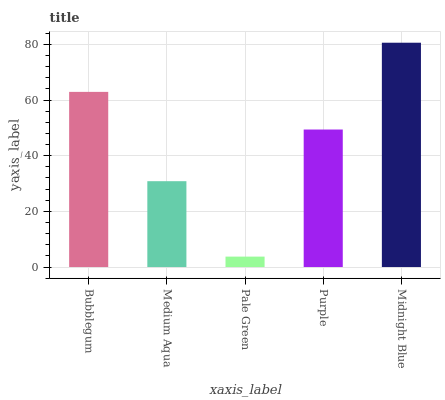Is Pale Green the minimum?
Answer yes or no. Yes. Is Midnight Blue the maximum?
Answer yes or no. Yes. Is Medium Aqua the minimum?
Answer yes or no. No. Is Medium Aqua the maximum?
Answer yes or no. No. Is Bubblegum greater than Medium Aqua?
Answer yes or no. Yes. Is Medium Aqua less than Bubblegum?
Answer yes or no. Yes. Is Medium Aqua greater than Bubblegum?
Answer yes or no. No. Is Bubblegum less than Medium Aqua?
Answer yes or no. No. Is Purple the high median?
Answer yes or no. Yes. Is Purple the low median?
Answer yes or no. Yes. Is Bubblegum the high median?
Answer yes or no. No. Is Medium Aqua the low median?
Answer yes or no. No. 